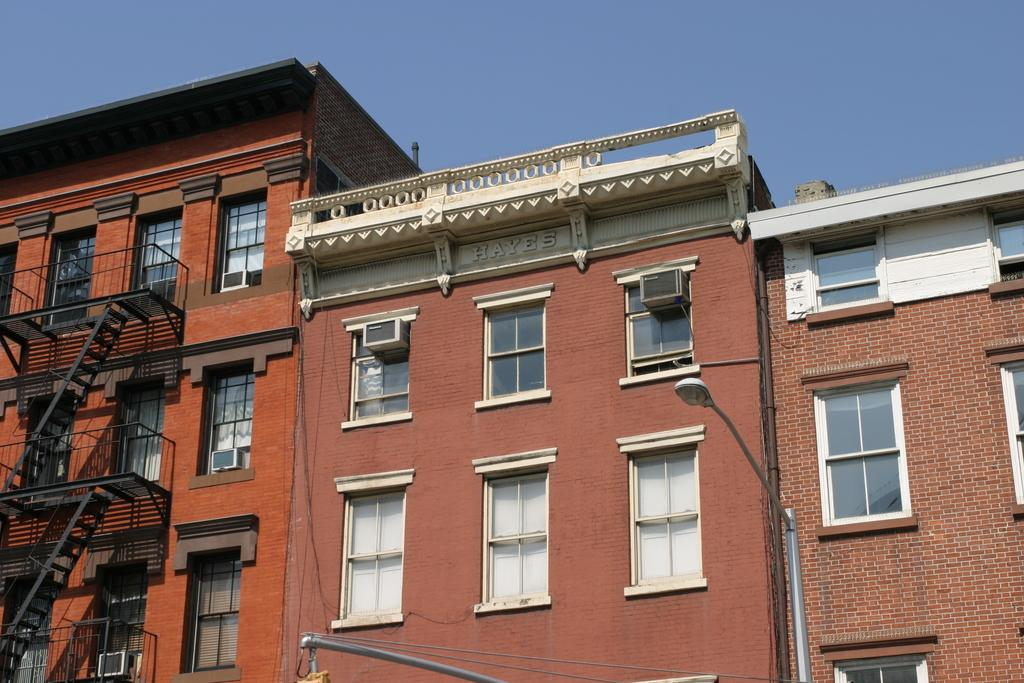What type of structures are present in the image? There are buildings in the image. Are there any specific features attached to the buildings? Yes, there are stairs attached to the buildings. What can be seen illuminating the area in the image? There is a street light in the image. What is visible at the top of the image? The sky is visible at the top of the image. Can you describe the zebra that is walking down the street in the image? There is no zebra present in the image; it only features buildings, stairs, a street light, and the sky. What type of transport is the stranger using to get around in the image? There is no stranger present in the image, and therefore no transport can be observed. 